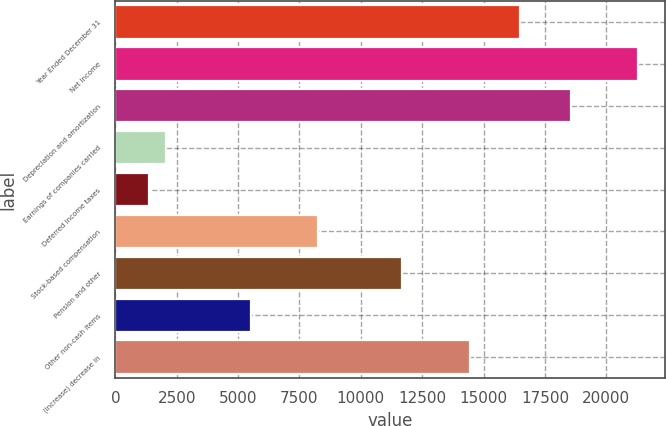<chart> <loc_0><loc_0><loc_500><loc_500><bar_chart><fcel>Year Ended December 31<fcel>Net Income<fcel>Depreciation and amortization<fcel>Earnings of companies carried<fcel>Deferred income taxes<fcel>Stock-based compensation<fcel>Pension and other<fcel>Other non-cash items<fcel>(Increase) decrease in<nl><fcel>16500.6<fcel>21308.9<fcel>18561.3<fcel>2075.7<fcel>1388.8<fcel>8257.8<fcel>11692.3<fcel>5510.2<fcel>14439.9<nl></chart> 